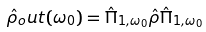Convert formula to latex. <formula><loc_0><loc_0><loc_500><loc_500>\hat { \rho } _ { o } u t ( \omega _ { 0 } ) = \hat { \Pi } _ { 1 , \omega _ { 0 } } \hat { \rho } \hat { \Pi } _ { 1 , \omega _ { 0 } }</formula> 